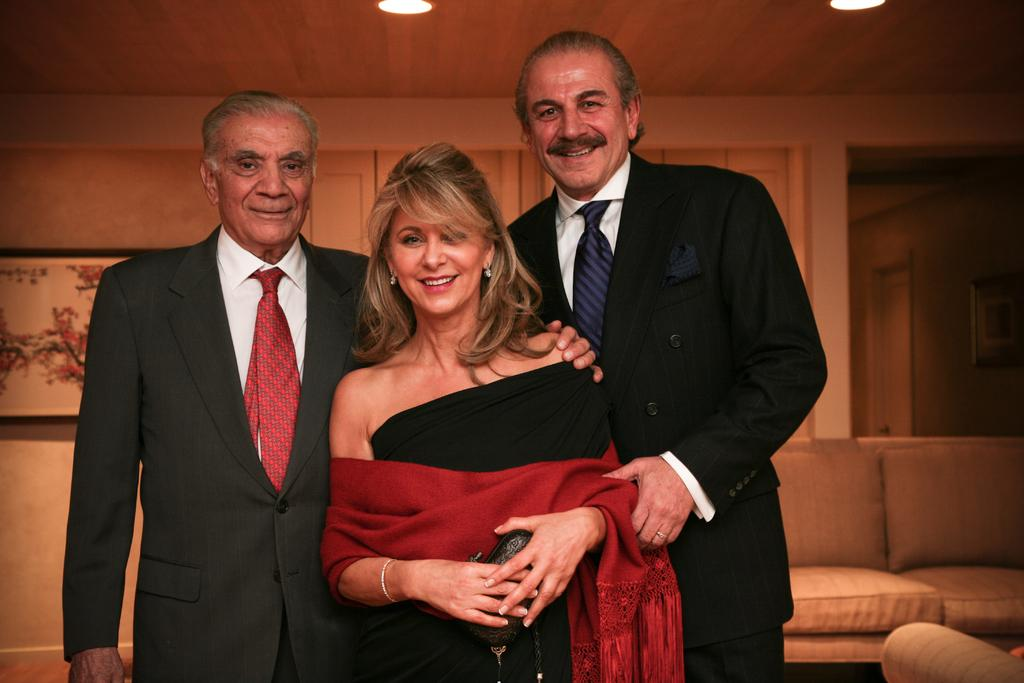How many people are in the image? There are two men and a woman in the image. What are the individuals in the image doing? The individuals are posing for a camera. What expressions do the individuals have? The individuals are smiling. What type of furniture is in the image? There is a sofa in the image. What can be seen in the background of the image? There is a frame, lights, and a wall in the background of the image. What type of smell can be detected in the image? There is no information about smells in the image, as it is a visual medium. --- Facts: 1. There is a car in the image. 2. The car is red. 3. The car has four wheels. 4. There is a road in the image. 5. The road is paved. 6. There are trees in the background of the image. Absurd Topics: dance, ocean, feather Conversation: What is the main subject of the image? The main subject of the image is a car. What color is the car? The car is red. How many wheels does the car have? The car has four wheels. What type of surface is the car on? There is a road in the image, and it is paved. What can be seen in the background of the image? There are trees in the background of the image. Reasoning: Let's think step by step in order to produce the conversation. We start by identifying the main subject of the image, which is the car. Then, we describe the car's color and the number of wheels it has. Next, we focus on the car's surroundings, mentioning the road and its paved surface. Finally, we describe the background elements, which are the trees. Each question is designed to elicit a specific detail about the image that is known from the provided facts. Absurd Question/Answer: Can you see any dancers performing near the car in the image? No, there are no dancers or any dance-related activities depicted in the image. 